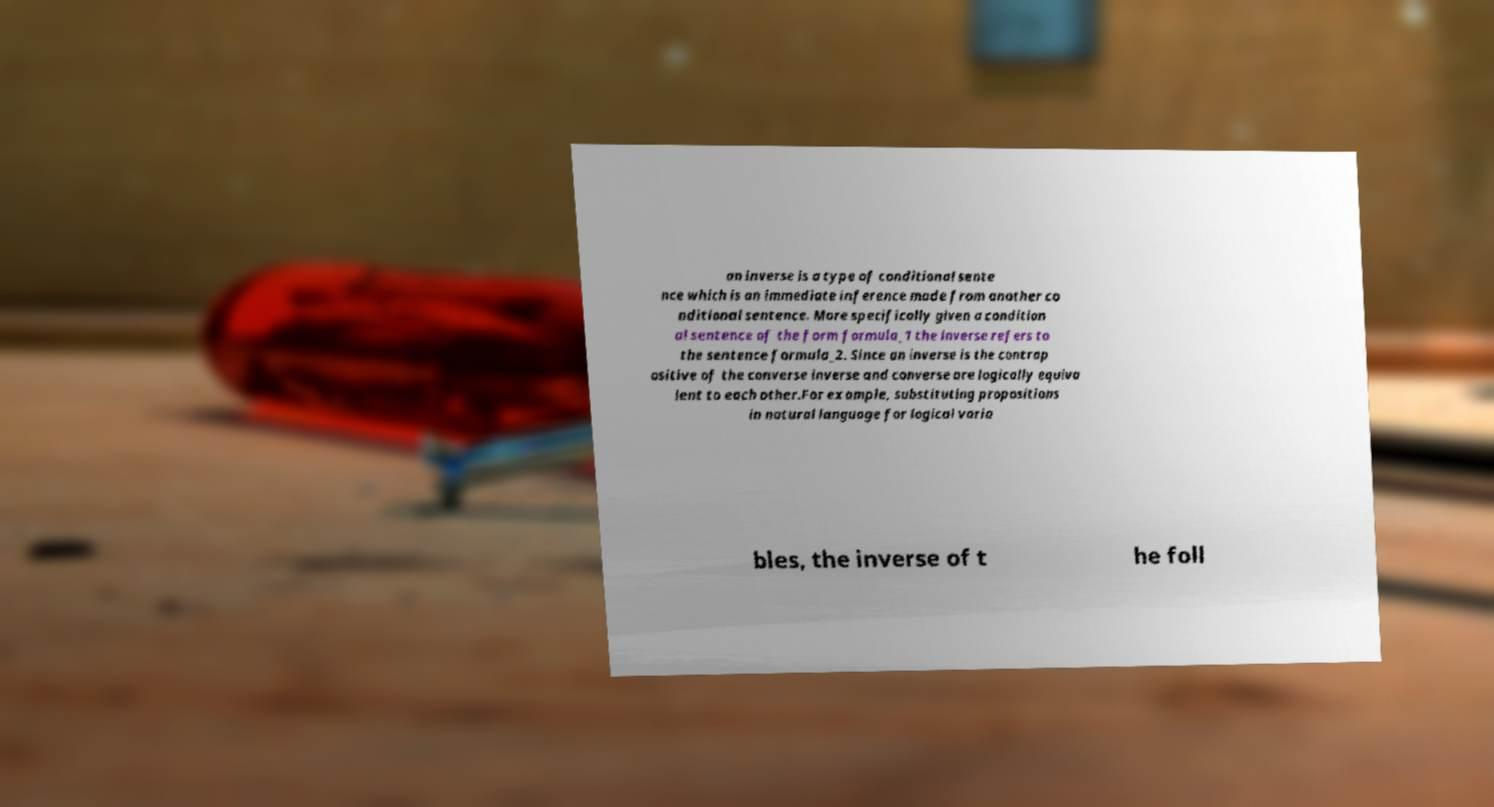Could you assist in decoding the text presented in this image and type it out clearly? an inverse is a type of conditional sente nce which is an immediate inference made from another co nditional sentence. More specifically given a condition al sentence of the form formula_1 the inverse refers to the sentence formula_2. Since an inverse is the contrap ositive of the converse inverse and converse are logically equiva lent to each other.For example, substituting propositions in natural language for logical varia bles, the inverse of t he foll 